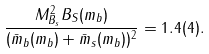Convert formula to latex. <formula><loc_0><loc_0><loc_500><loc_500>\frac { M ^ { 2 } _ { B _ { s } } B _ { S } ( m _ { b } ) } { ( \bar { m } _ { b } ( m _ { b } ) + \bar { m } _ { s } ( m _ { b } ) ) ^ { 2 } } = 1 . 4 ( 4 ) .</formula> 